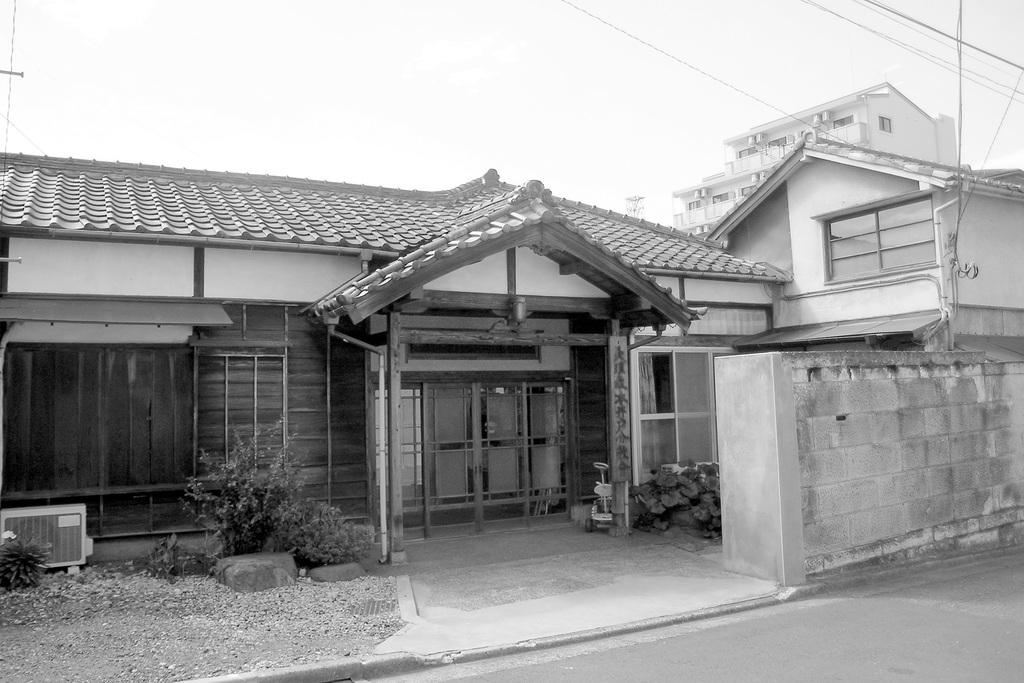What type of view is shown in the image? There is a front view of a house in the image. What is located near the house? There is a plant in the image. What is visible in the background of the image? There is a road, a building, and wires in the image. What can be seen above the house and other structures? The sky is visible in the image. What type of net is being used by the group of authorities in the image? There is no net or group of authorities present in the image. 